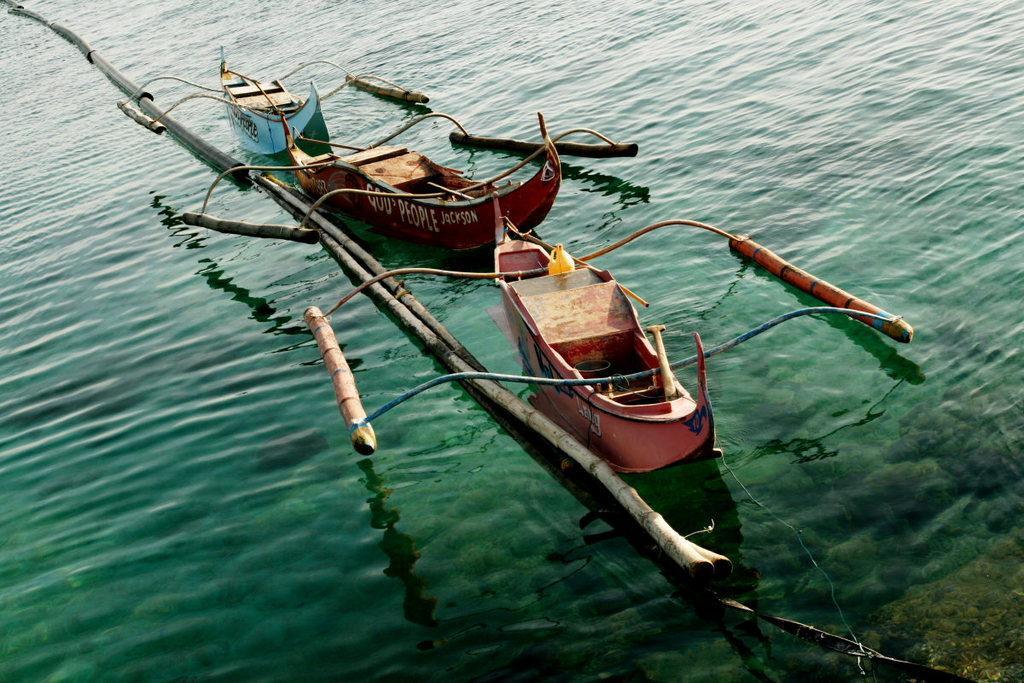In one or two sentences, can you explain what this image depicts? In this picture I can see the three boats on the water, beside them there are logs. 